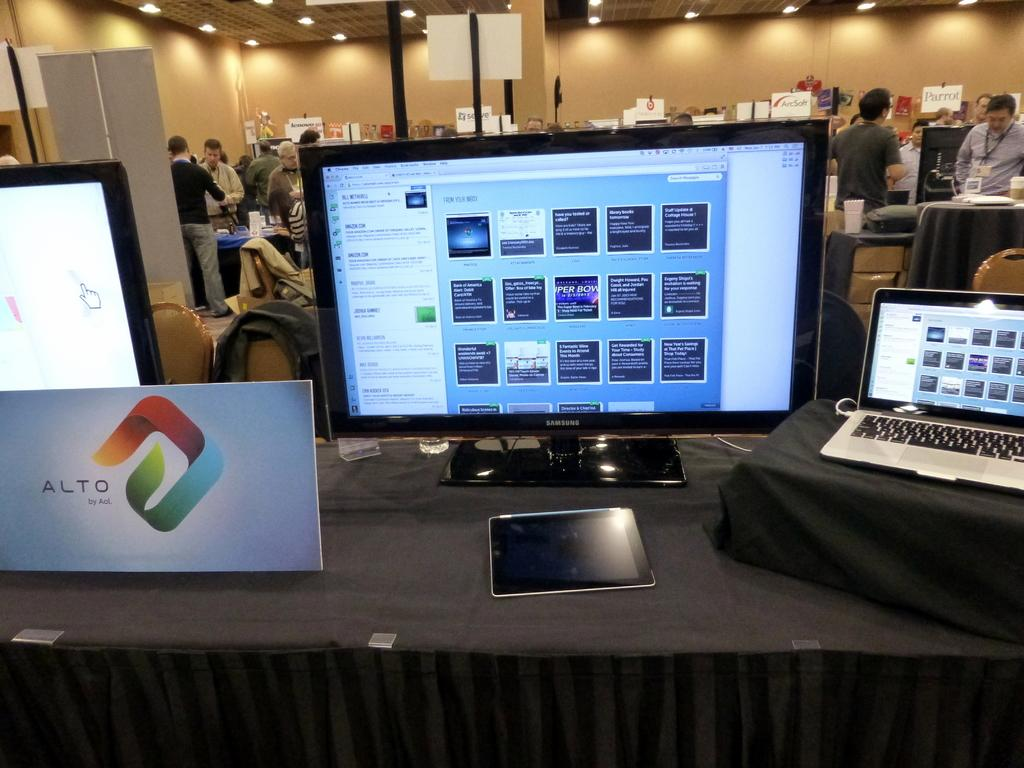<image>
Relay a brief, clear account of the picture shown. a sign in front of a computer that says Alto 